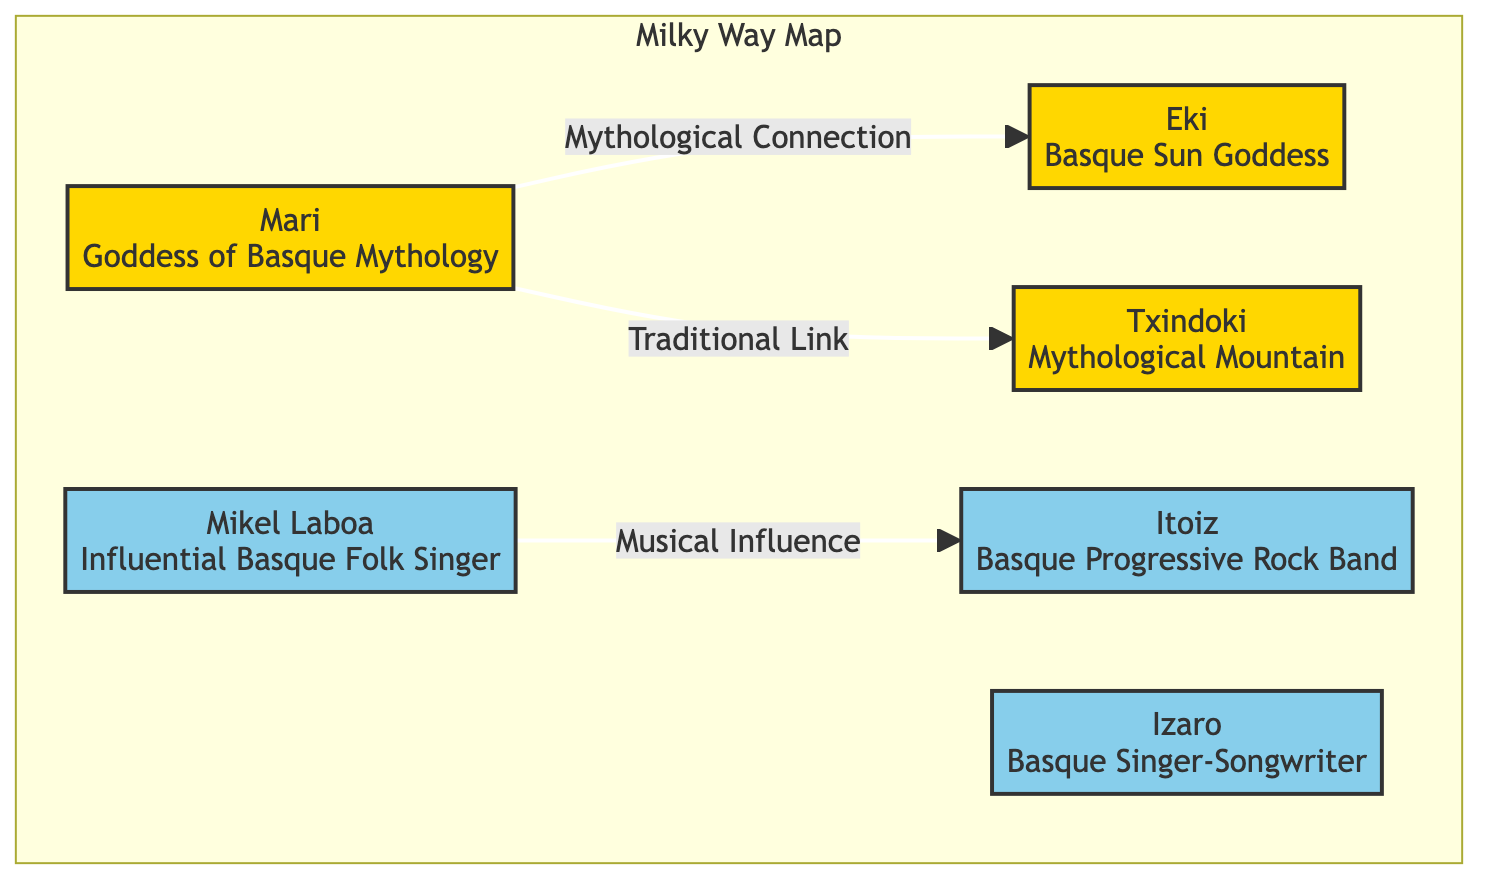What is the name of the mythology goddess highlighted in the diagram? The diagram highlights "Mari," who is identified as the goddess of Basque mythology. This information is clearly labeled in the first node of the diagram.
Answer: Mari How many musicians are mentioned in the diagram? There are three musicians listed in the diagram: Mikel Laboa, Itoiz, and Izaro. By counting the nodes designated with a musician class, we find this total.
Answer: 3 What type of connection exists between Mari and Eki? The relationship is labeled as "Mythological Connection" seen in the arrow leading from the node Mari to the node Eki in the diagram, indicating a connection of this nature.
Answer: Mythological Connection Which mythological mountain is represented in the diagram? The diagram includes "Txindoki," which is specifically labeled as the mythological mountain associated within the Basque tradition, appearing in the context of the mythology-related nodes.
Answer: Txindoki What genre of music is associated with the band Itoiz? The band Itoiz is categorized under "Basque Progressive Rock Band" in the diagram. The label attached to this node indicates the genre clearly.
Answer: Progressive Rock How many total nodes are there in the diagram? Counting all the nodes present in the diagram, including those related to mythology and musicians, we find a total of six nodes represented visually.
Answer: 6 What traditional connection does Mari have in the diagram? Mari has a "Traditional Link" to the mythological mountain Txindoki. This connection is indicated by a directed edge linking the two nodes, specifying the nature of their relationship.
Answer: Traditional Link Which musician's influence is connected to the band Itoiz? The musician Mikel Laboa has a connection labeled as "Musical Influence" reaching out towards the band Itoiz, as shown in the illustrative relationship indicated in the diagram.
Answer: Mikel Laboa What type of node is Izaro categorized as? Izaro is classified as a musician in the diagram, which is clear from its designation within the musicianClass. This is visually supported by the color coding and classification styles used.
Answer: Musician 